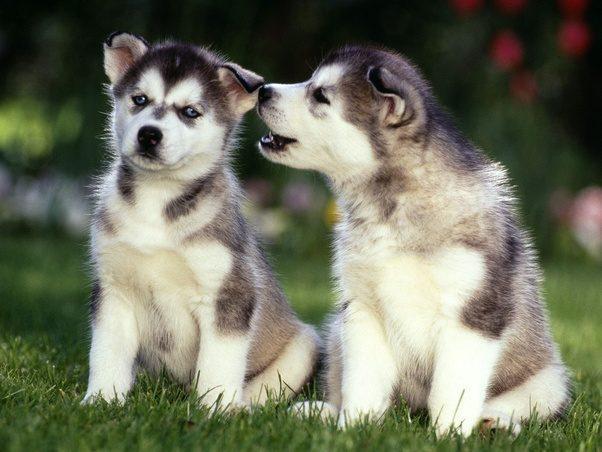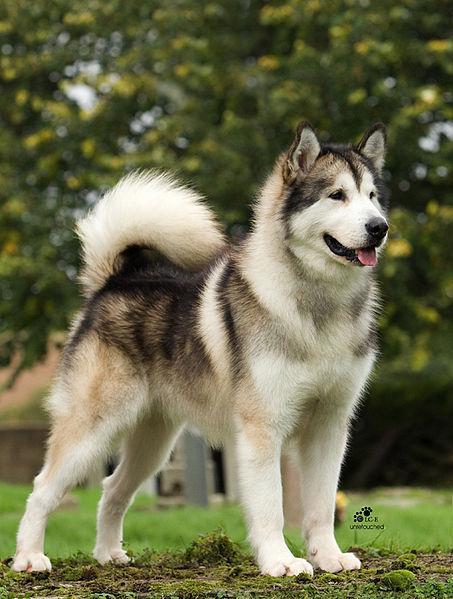The first image is the image on the left, the second image is the image on the right. Given the left and right images, does the statement "A dog is standing." hold true? Answer yes or no. Yes. The first image is the image on the left, the second image is the image on the right. Analyze the images presented: Is the assertion "There is a single puppy husky with blue eyes and white, black fur laying in the grass." valid? Answer yes or no. No. 